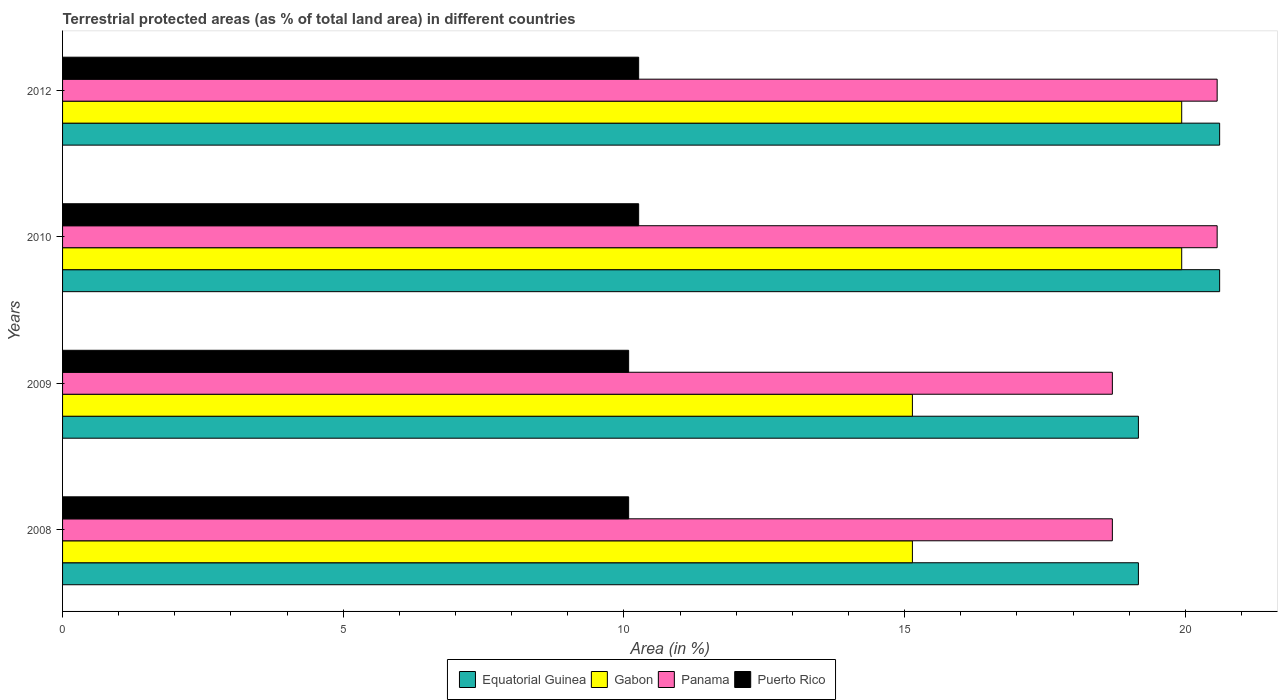How many different coloured bars are there?
Offer a terse response. 4. How many bars are there on the 2nd tick from the bottom?
Ensure brevity in your answer.  4. What is the label of the 1st group of bars from the top?
Ensure brevity in your answer.  2012. In how many cases, is the number of bars for a given year not equal to the number of legend labels?
Offer a terse response. 0. What is the percentage of terrestrial protected land in Panama in 2008?
Offer a terse response. 18.7. Across all years, what is the maximum percentage of terrestrial protected land in Gabon?
Your answer should be very brief. 19.94. Across all years, what is the minimum percentage of terrestrial protected land in Panama?
Keep it short and to the point. 18.7. In which year was the percentage of terrestrial protected land in Panama minimum?
Your response must be concise. 2008. What is the total percentage of terrestrial protected land in Puerto Rico in the graph?
Your response must be concise. 40.69. What is the difference between the percentage of terrestrial protected land in Gabon in 2008 and that in 2010?
Your answer should be very brief. -4.8. What is the difference between the percentage of terrestrial protected land in Panama in 2009 and the percentage of terrestrial protected land in Gabon in 2008?
Make the answer very short. 3.56. What is the average percentage of terrestrial protected land in Panama per year?
Offer a very short reply. 19.63. In the year 2008, what is the difference between the percentage of terrestrial protected land in Gabon and percentage of terrestrial protected land in Panama?
Offer a very short reply. -3.56. What is the ratio of the percentage of terrestrial protected land in Puerto Rico in 2010 to that in 2012?
Your response must be concise. 1. What is the difference between the highest and the second highest percentage of terrestrial protected land in Puerto Rico?
Provide a succinct answer. 3.7610092817885743e-10. What is the difference between the highest and the lowest percentage of terrestrial protected land in Puerto Rico?
Keep it short and to the point. 0.18. In how many years, is the percentage of terrestrial protected land in Puerto Rico greater than the average percentage of terrestrial protected land in Puerto Rico taken over all years?
Offer a very short reply. 2. Is the sum of the percentage of terrestrial protected land in Gabon in 2008 and 2010 greater than the maximum percentage of terrestrial protected land in Panama across all years?
Provide a short and direct response. Yes. What does the 4th bar from the top in 2010 represents?
Offer a terse response. Equatorial Guinea. What does the 4th bar from the bottom in 2008 represents?
Your answer should be compact. Puerto Rico. How many bars are there?
Make the answer very short. 16. Are all the bars in the graph horizontal?
Provide a short and direct response. Yes. How many years are there in the graph?
Ensure brevity in your answer.  4. Does the graph contain grids?
Give a very brief answer. No. What is the title of the graph?
Make the answer very short. Terrestrial protected areas (as % of total land area) in different countries. What is the label or title of the X-axis?
Your answer should be very brief. Area (in %). What is the label or title of the Y-axis?
Give a very brief answer. Years. What is the Area (in %) of Equatorial Guinea in 2008?
Offer a terse response. 19.16. What is the Area (in %) in Gabon in 2008?
Your answer should be compact. 15.14. What is the Area (in %) of Panama in 2008?
Keep it short and to the point. 18.7. What is the Area (in %) of Puerto Rico in 2008?
Give a very brief answer. 10.08. What is the Area (in %) in Equatorial Guinea in 2009?
Offer a very short reply. 19.16. What is the Area (in %) of Gabon in 2009?
Provide a short and direct response. 15.14. What is the Area (in %) of Panama in 2009?
Keep it short and to the point. 18.7. What is the Area (in %) in Puerto Rico in 2009?
Keep it short and to the point. 10.08. What is the Area (in %) of Equatorial Guinea in 2010?
Offer a very short reply. 20.61. What is the Area (in %) of Gabon in 2010?
Your answer should be compact. 19.94. What is the Area (in %) of Panama in 2010?
Provide a succinct answer. 20.57. What is the Area (in %) in Puerto Rico in 2010?
Give a very brief answer. 10.26. What is the Area (in %) in Equatorial Guinea in 2012?
Your answer should be compact. 20.61. What is the Area (in %) in Gabon in 2012?
Your answer should be very brief. 19.94. What is the Area (in %) of Panama in 2012?
Ensure brevity in your answer.  20.57. What is the Area (in %) of Puerto Rico in 2012?
Your answer should be very brief. 10.26. Across all years, what is the maximum Area (in %) of Equatorial Guinea?
Provide a succinct answer. 20.61. Across all years, what is the maximum Area (in %) in Gabon?
Ensure brevity in your answer.  19.94. Across all years, what is the maximum Area (in %) of Panama?
Provide a short and direct response. 20.57. Across all years, what is the maximum Area (in %) of Puerto Rico?
Keep it short and to the point. 10.26. Across all years, what is the minimum Area (in %) of Equatorial Guinea?
Provide a succinct answer. 19.16. Across all years, what is the minimum Area (in %) in Gabon?
Ensure brevity in your answer.  15.14. Across all years, what is the minimum Area (in %) of Panama?
Make the answer very short. 18.7. Across all years, what is the minimum Area (in %) in Puerto Rico?
Your answer should be very brief. 10.08. What is the total Area (in %) of Equatorial Guinea in the graph?
Provide a succinct answer. 79.55. What is the total Area (in %) in Gabon in the graph?
Give a very brief answer. 70.15. What is the total Area (in %) of Panama in the graph?
Your answer should be compact. 78.53. What is the total Area (in %) in Puerto Rico in the graph?
Your answer should be very brief. 40.69. What is the difference between the Area (in %) of Panama in 2008 and that in 2009?
Your answer should be very brief. 0. What is the difference between the Area (in %) in Puerto Rico in 2008 and that in 2009?
Keep it short and to the point. 0. What is the difference between the Area (in %) in Equatorial Guinea in 2008 and that in 2010?
Your answer should be compact. -1.45. What is the difference between the Area (in %) of Gabon in 2008 and that in 2010?
Provide a succinct answer. -4.8. What is the difference between the Area (in %) in Panama in 2008 and that in 2010?
Offer a very short reply. -1.87. What is the difference between the Area (in %) of Puerto Rico in 2008 and that in 2010?
Provide a succinct answer. -0.18. What is the difference between the Area (in %) of Equatorial Guinea in 2008 and that in 2012?
Provide a short and direct response. -1.45. What is the difference between the Area (in %) of Gabon in 2008 and that in 2012?
Make the answer very short. -4.8. What is the difference between the Area (in %) in Panama in 2008 and that in 2012?
Keep it short and to the point. -1.87. What is the difference between the Area (in %) of Puerto Rico in 2008 and that in 2012?
Ensure brevity in your answer.  -0.18. What is the difference between the Area (in %) in Equatorial Guinea in 2009 and that in 2010?
Ensure brevity in your answer.  -1.45. What is the difference between the Area (in %) in Gabon in 2009 and that in 2010?
Your response must be concise. -4.8. What is the difference between the Area (in %) of Panama in 2009 and that in 2010?
Keep it short and to the point. -1.87. What is the difference between the Area (in %) of Puerto Rico in 2009 and that in 2010?
Your response must be concise. -0.18. What is the difference between the Area (in %) in Equatorial Guinea in 2009 and that in 2012?
Your answer should be compact. -1.45. What is the difference between the Area (in %) in Gabon in 2009 and that in 2012?
Offer a terse response. -4.8. What is the difference between the Area (in %) of Panama in 2009 and that in 2012?
Your answer should be very brief. -1.87. What is the difference between the Area (in %) in Puerto Rico in 2009 and that in 2012?
Your answer should be very brief. -0.18. What is the difference between the Area (in %) in Equatorial Guinea in 2008 and the Area (in %) in Gabon in 2009?
Keep it short and to the point. 4.03. What is the difference between the Area (in %) of Equatorial Guinea in 2008 and the Area (in %) of Panama in 2009?
Offer a terse response. 0.46. What is the difference between the Area (in %) in Equatorial Guinea in 2008 and the Area (in %) in Puerto Rico in 2009?
Make the answer very short. 9.08. What is the difference between the Area (in %) in Gabon in 2008 and the Area (in %) in Panama in 2009?
Ensure brevity in your answer.  -3.56. What is the difference between the Area (in %) of Gabon in 2008 and the Area (in %) of Puerto Rico in 2009?
Provide a short and direct response. 5.05. What is the difference between the Area (in %) of Panama in 2008 and the Area (in %) of Puerto Rico in 2009?
Keep it short and to the point. 8.62. What is the difference between the Area (in %) of Equatorial Guinea in 2008 and the Area (in %) of Gabon in 2010?
Your answer should be compact. -0.77. What is the difference between the Area (in %) in Equatorial Guinea in 2008 and the Area (in %) in Panama in 2010?
Provide a short and direct response. -1.4. What is the difference between the Area (in %) in Equatorial Guinea in 2008 and the Area (in %) in Puerto Rico in 2010?
Offer a terse response. 8.9. What is the difference between the Area (in %) in Gabon in 2008 and the Area (in %) in Panama in 2010?
Provide a succinct answer. -5.43. What is the difference between the Area (in %) of Gabon in 2008 and the Area (in %) of Puerto Rico in 2010?
Make the answer very short. 4.88. What is the difference between the Area (in %) of Panama in 2008 and the Area (in %) of Puerto Rico in 2010?
Provide a short and direct response. 8.44. What is the difference between the Area (in %) of Equatorial Guinea in 2008 and the Area (in %) of Gabon in 2012?
Offer a very short reply. -0.77. What is the difference between the Area (in %) in Equatorial Guinea in 2008 and the Area (in %) in Panama in 2012?
Make the answer very short. -1.4. What is the difference between the Area (in %) in Equatorial Guinea in 2008 and the Area (in %) in Puerto Rico in 2012?
Offer a very short reply. 8.9. What is the difference between the Area (in %) in Gabon in 2008 and the Area (in %) in Panama in 2012?
Make the answer very short. -5.43. What is the difference between the Area (in %) of Gabon in 2008 and the Area (in %) of Puerto Rico in 2012?
Your response must be concise. 4.88. What is the difference between the Area (in %) of Panama in 2008 and the Area (in %) of Puerto Rico in 2012?
Your answer should be compact. 8.44. What is the difference between the Area (in %) of Equatorial Guinea in 2009 and the Area (in %) of Gabon in 2010?
Ensure brevity in your answer.  -0.77. What is the difference between the Area (in %) of Equatorial Guinea in 2009 and the Area (in %) of Panama in 2010?
Keep it short and to the point. -1.4. What is the difference between the Area (in %) of Equatorial Guinea in 2009 and the Area (in %) of Puerto Rico in 2010?
Your response must be concise. 8.9. What is the difference between the Area (in %) of Gabon in 2009 and the Area (in %) of Panama in 2010?
Offer a terse response. -5.43. What is the difference between the Area (in %) in Gabon in 2009 and the Area (in %) in Puerto Rico in 2010?
Provide a short and direct response. 4.88. What is the difference between the Area (in %) of Panama in 2009 and the Area (in %) of Puerto Rico in 2010?
Your answer should be compact. 8.44. What is the difference between the Area (in %) of Equatorial Guinea in 2009 and the Area (in %) of Gabon in 2012?
Offer a terse response. -0.77. What is the difference between the Area (in %) in Equatorial Guinea in 2009 and the Area (in %) in Panama in 2012?
Keep it short and to the point. -1.4. What is the difference between the Area (in %) of Equatorial Guinea in 2009 and the Area (in %) of Puerto Rico in 2012?
Give a very brief answer. 8.9. What is the difference between the Area (in %) in Gabon in 2009 and the Area (in %) in Panama in 2012?
Your answer should be compact. -5.43. What is the difference between the Area (in %) of Gabon in 2009 and the Area (in %) of Puerto Rico in 2012?
Offer a very short reply. 4.88. What is the difference between the Area (in %) in Panama in 2009 and the Area (in %) in Puerto Rico in 2012?
Provide a succinct answer. 8.44. What is the difference between the Area (in %) of Equatorial Guinea in 2010 and the Area (in %) of Gabon in 2012?
Offer a very short reply. 0.68. What is the difference between the Area (in %) of Equatorial Guinea in 2010 and the Area (in %) of Panama in 2012?
Offer a very short reply. 0.04. What is the difference between the Area (in %) of Equatorial Guinea in 2010 and the Area (in %) of Puerto Rico in 2012?
Give a very brief answer. 10.35. What is the difference between the Area (in %) in Gabon in 2010 and the Area (in %) in Panama in 2012?
Provide a succinct answer. -0.63. What is the difference between the Area (in %) in Gabon in 2010 and the Area (in %) in Puerto Rico in 2012?
Ensure brevity in your answer.  9.67. What is the difference between the Area (in %) of Panama in 2010 and the Area (in %) of Puerto Rico in 2012?
Offer a terse response. 10.3. What is the average Area (in %) in Equatorial Guinea per year?
Provide a short and direct response. 19.89. What is the average Area (in %) of Gabon per year?
Offer a very short reply. 17.54. What is the average Area (in %) of Panama per year?
Keep it short and to the point. 19.63. What is the average Area (in %) in Puerto Rico per year?
Make the answer very short. 10.17. In the year 2008, what is the difference between the Area (in %) of Equatorial Guinea and Area (in %) of Gabon?
Provide a succinct answer. 4.03. In the year 2008, what is the difference between the Area (in %) in Equatorial Guinea and Area (in %) in Panama?
Provide a short and direct response. 0.46. In the year 2008, what is the difference between the Area (in %) in Equatorial Guinea and Area (in %) in Puerto Rico?
Your response must be concise. 9.08. In the year 2008, what is the difference between the Area (in %) of Gabon and Area (in %) of Panama?
Provide a succinct answer. -3.56. In the year 2008, what is the difference between the Area (in %) in Gabon and Area (in %) in Puerto Rico?
Provide a succinct answer. 5.05. In the year 2008, what is the difference between the Area (in %) in Panama and Area (in %) in Puerto Rico?
Make the answer very short. 8.62. In the year 2009, what is the difference between the Area (in %) of Equatorial Guinea and Area (in %) of Gabon?
Keep it short and to the point. 4.03. In the year 2009, what is the difference between the Area (in %) of Equatorial Guinea and Area (in %) of Panama?
Offer a terse response. 0.46. In the year 2009, what is the difference between the Area (in %) of Equatorial Guinea and Area (in %) of Puerto Rico?
Offer a terse response. 9.08. In the year 2009, what is the difference between the Area (in %) of Gabon and Area (in %) of Panama?
Offer a very short reply. -3.56. In the year 2009, what is the difference between the Area (in %) of Gabon and Area (in %) of Puerto Rico?
Keep it short and to the point. 5.05. In the year 2009, what is the difference between the Area (in %) of Panama and Area (in %) of Puerto Rico?
Give a very brief answer. 8.62. In the year 2010, what is the difference between the Area (in %) of Equatorial Guinea and Area (in %) of Gabon?
Ensure brevity in your answer.  0.68. In the year 2010, what is the difference between the Area (in %) of Equatorial Guinea and Area (in %) of Panama?
Provide a short and direct response. 0.04. In the year 2010, what is the difference between the Area (in %) in Equatorial Guinea and Area (in %) in Puerto Rico?
Provide a succinct answer. 10.35. In the year 2010, what is the difference between the Area (in %) of Gabon and Area (in %) of Panama?
Make the answer very short. -0.63. In the year 2010, what is the difference between the Area (in %) in Gabon and Area (in %) in Puerto Rico?
Give a very brief answer. 9.67. In the year 2010, what is the difference between the Area (in %) in Panama and Area (in %) in Puerto Rico?
Your response must be concise. 10.3. In the year 2012, what is the difference between the Area (in %) of Equatorial Guinea and Area (in %) of Gabon?
Offer a terse response. 0.68. In the year 2012, what is the difference between the Area (in %) in Equatorial Guinea and Area (in %) in Panama?
Give a very brief answer. 0.04. In the year 2012, what is the difference between the Area (in %) of Equatorial Guinea and Area (in %) of Puerto Rico?
Offer a very short reply. 10.35. In the year 2012, what is the difference between the Area (in %) in Gabon and Area (in %) in Panama?
Provide a succinct answer. -0.63. In the year 2012, what is the difference between the Area (in %) in Gabon and Area (in %) in Puerto Rico?
Ensure brevity in your answer.  9.67. In the year 2012, what is the difference between the Area (in %) of Panama and Area (in %) of Puerto Rico?
Your response must be concise. 10.3. What is the ratio of the Area (in %) of Panama in 2008 to that in 2009?
Give a very brief answer. 1. What is the ratio of the Area (in %) in Puerto Rico in 2008 to that in 2009?
Give a very brief answer. 1. What is the ratio of the Area (in %) of Equatorial Guinea in 2008 to that in 2010?
Make the answer very short. 0.93. What is the ratio of the Area (in %) in Gabon in 2008 to that in 2010?
Keep it short and to the point. 0.76. What is the ratio of the Area (in %) of Panama in 2008 to that in 2010?
Provide a succinct answer. 0.91. What is the ratio of the Area (in %) of Puerto Rico in 2008 to that in 2010?
Provide a short and direct response. 0.98. What is the ratio of the Area (in %) of Equatorial Guinea in 2008 to that in 2012?
Your answer should be very brief. 0.93. What is the ratio of the Area (in %) in Gabon in 2008 to that in 2012?
Offer a very short reply. 0.76. What is the ratio of the Area (in %) of Panama in 2008 to that in 2012?
Provide a succinct answer. 0.91. What is the ratio of the Area (in %) in Puerto Rico in 2008 to that in 2012?
Offer a very short reply. 0.98. What is the ratio of the Area (in %) in Equatorial Guinea in 2009 to that in 2010?
Provide a short and direct response. 0.93. What is the ratio of the Area (in %) of Gabon in 2009 to that in 2010?
Provide a short and direct response. 0.76. What is the ratio of the Area (in %) in Panama in 2009 to that in 2010?
Your answer should be very brief. 0.91. What is the ratio of the Area (in %) in Puerto Rico in 2009 to that in 2010?
Provide a short and direct response. 0.98. What is the ratio of the Area (in %) of Equatorial Guinea in 2009 to that in 2012?
Your response must be concise. 0.93. What is the ratio of the Area (in %) of Gabon in 2009 to that in 2012?
Your answer should be very brief. 0.76. What is the ratio of the Area (in %) in Panama in 2009 to that in 2012?
Provide a succinct answer. 0.91. What is the ratio of the Area (in %) of Puerto Rico in 2009 to that in 2012?
Give a very brief answer. 0.98. What is the ratio of the Area (in %) of Equatorial Guinea in 2010 to that in 2012?
Your answer should be compact. 1. What is the ratio of the Area (in %) of Panama in 2010 to that in 2012?
Offer a very short reply. 1. What is the ratio of the Area (in %) of Puerto Rico in 2010 to that in 2012?
Your answer should be compact. 1. What is the difference between the highest and the second highest Area (in %) of Gabon?
Your answer should be very brief. 0. What is the difference between the highest and the second highest Area (in %) of Panama?
Make the answer very short. 0. What is the difference between the highest and the lowest Area (in %) of Equatorial Guinea?
Provide a short and direct response. 1.45. What is the difference between the highest and the lowest Area (in %) in Gabon?
Give a very brief answer. 4.8. What is the difference between the highest and the lowest Area (in %) in Panama?
Offer a terse response. 1.87. What is the difference between the highest and the lowest Area (in %) in Puerto Rico?
Your response must be concise. 0.18. 